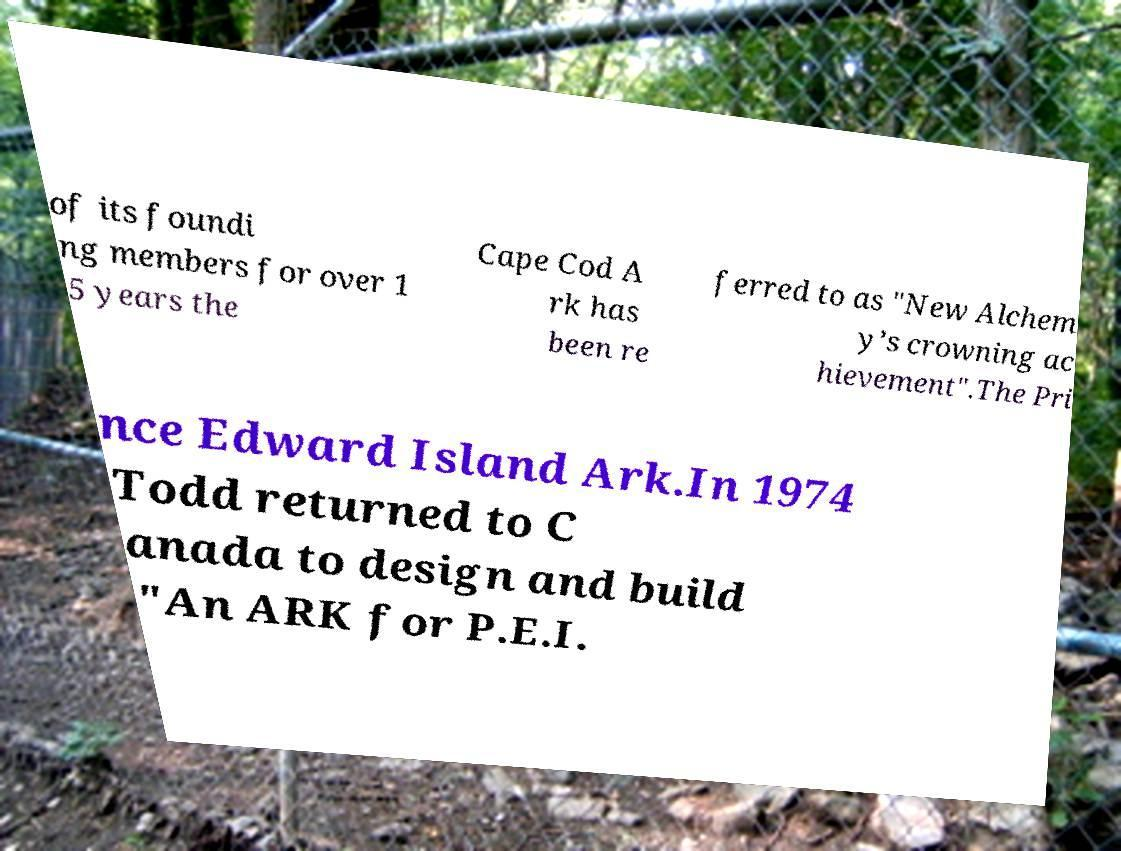Please read and relay the text visible in this image. What does it say? of its foundi ng members for over 1 5 years the Cape Cod A rk has been re ferred to as "New Alchem y’s crowning ac hievement".The Pri nce Edward Island Ark.In 1974 Todd returned to C anada to design and build "An ARK for P.E.I. 